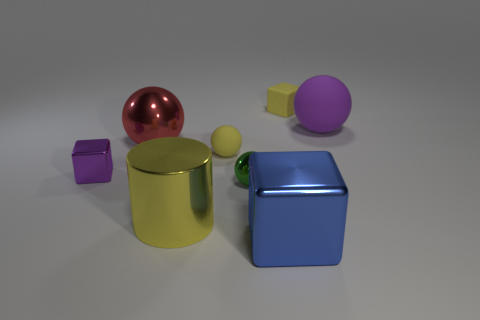Add 1 small metallic balls. How many objects exist? 9 Subtract all cubes. How many objects are left? 5 Add 3 big red things. How many big red things exist? 4 Subtract 0 brown spheres. How many objects are left? 8 Subtract all metallic spheres. Subtract all small purple blocks. How many objects are left? 5 Add 7 large yellow shiny things. How many large yellow shiny things are left? 8 